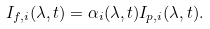Convert formula to latex. <formula><loc_0><loc_0><loc_500><loc_500>I _ { f , i } ( \lambda , t ) = \alpha _ { i } ( \lambda , t ) I _ { p , i } ( \lambda , t ) .</formula> 